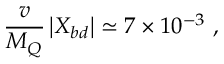<formula> <loc_0><loc_0><loc_500><loc_500>\frac { v } { M _ { Q } } \left | X _ { b d } \right | \simeq 7 \times 1 0 ^ { - 3 } \ ,</formula> 